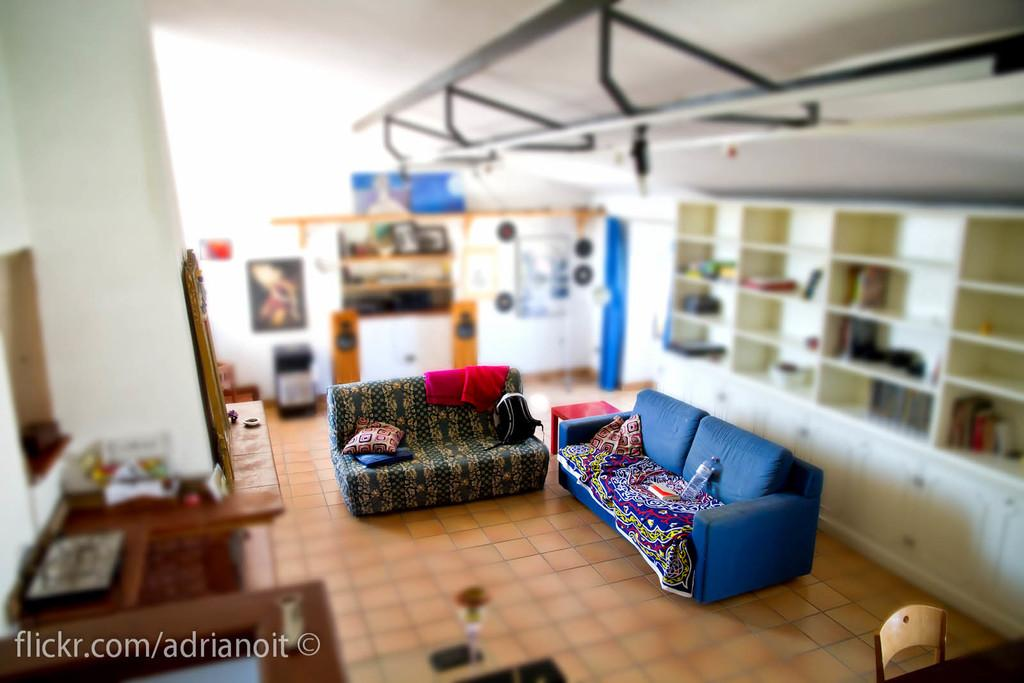Provide a one-sentence caption for the provided image. A photo of a living room from the Flickr account Adrinoit. 